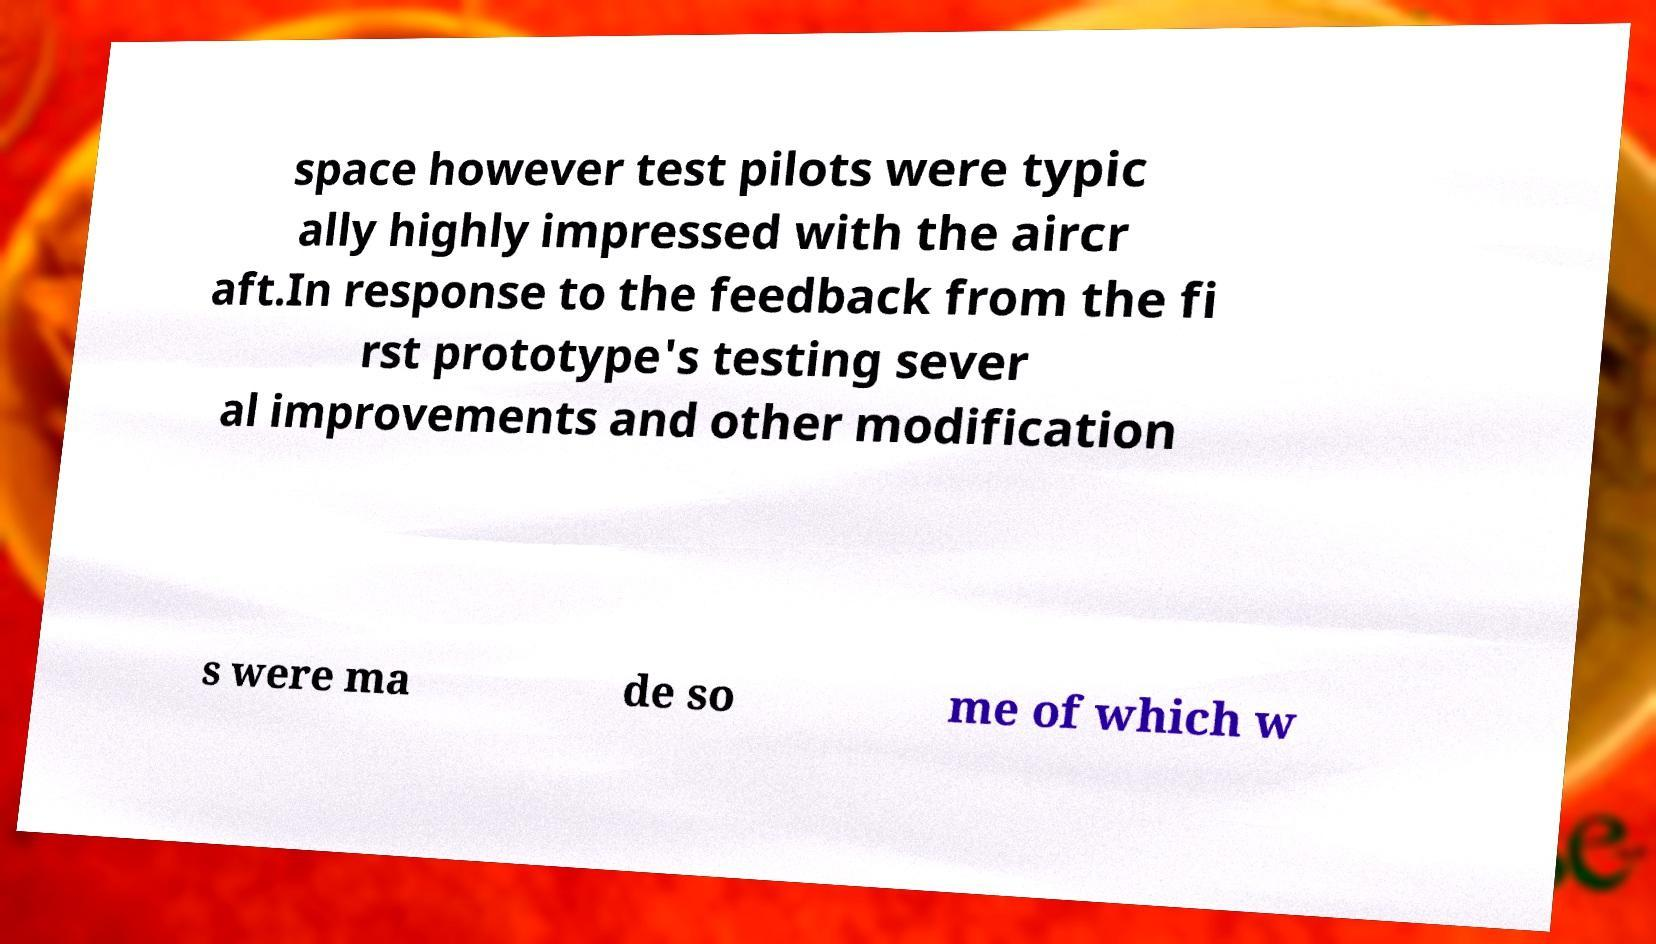I need the written content from this picture converted into text. Can you do that? space however test pilots were typic ally highly impressed with the aircr aft.In response to the feedback from the fi rst prototype's testing sever al improvements and other modification s were ma de so me of which w 